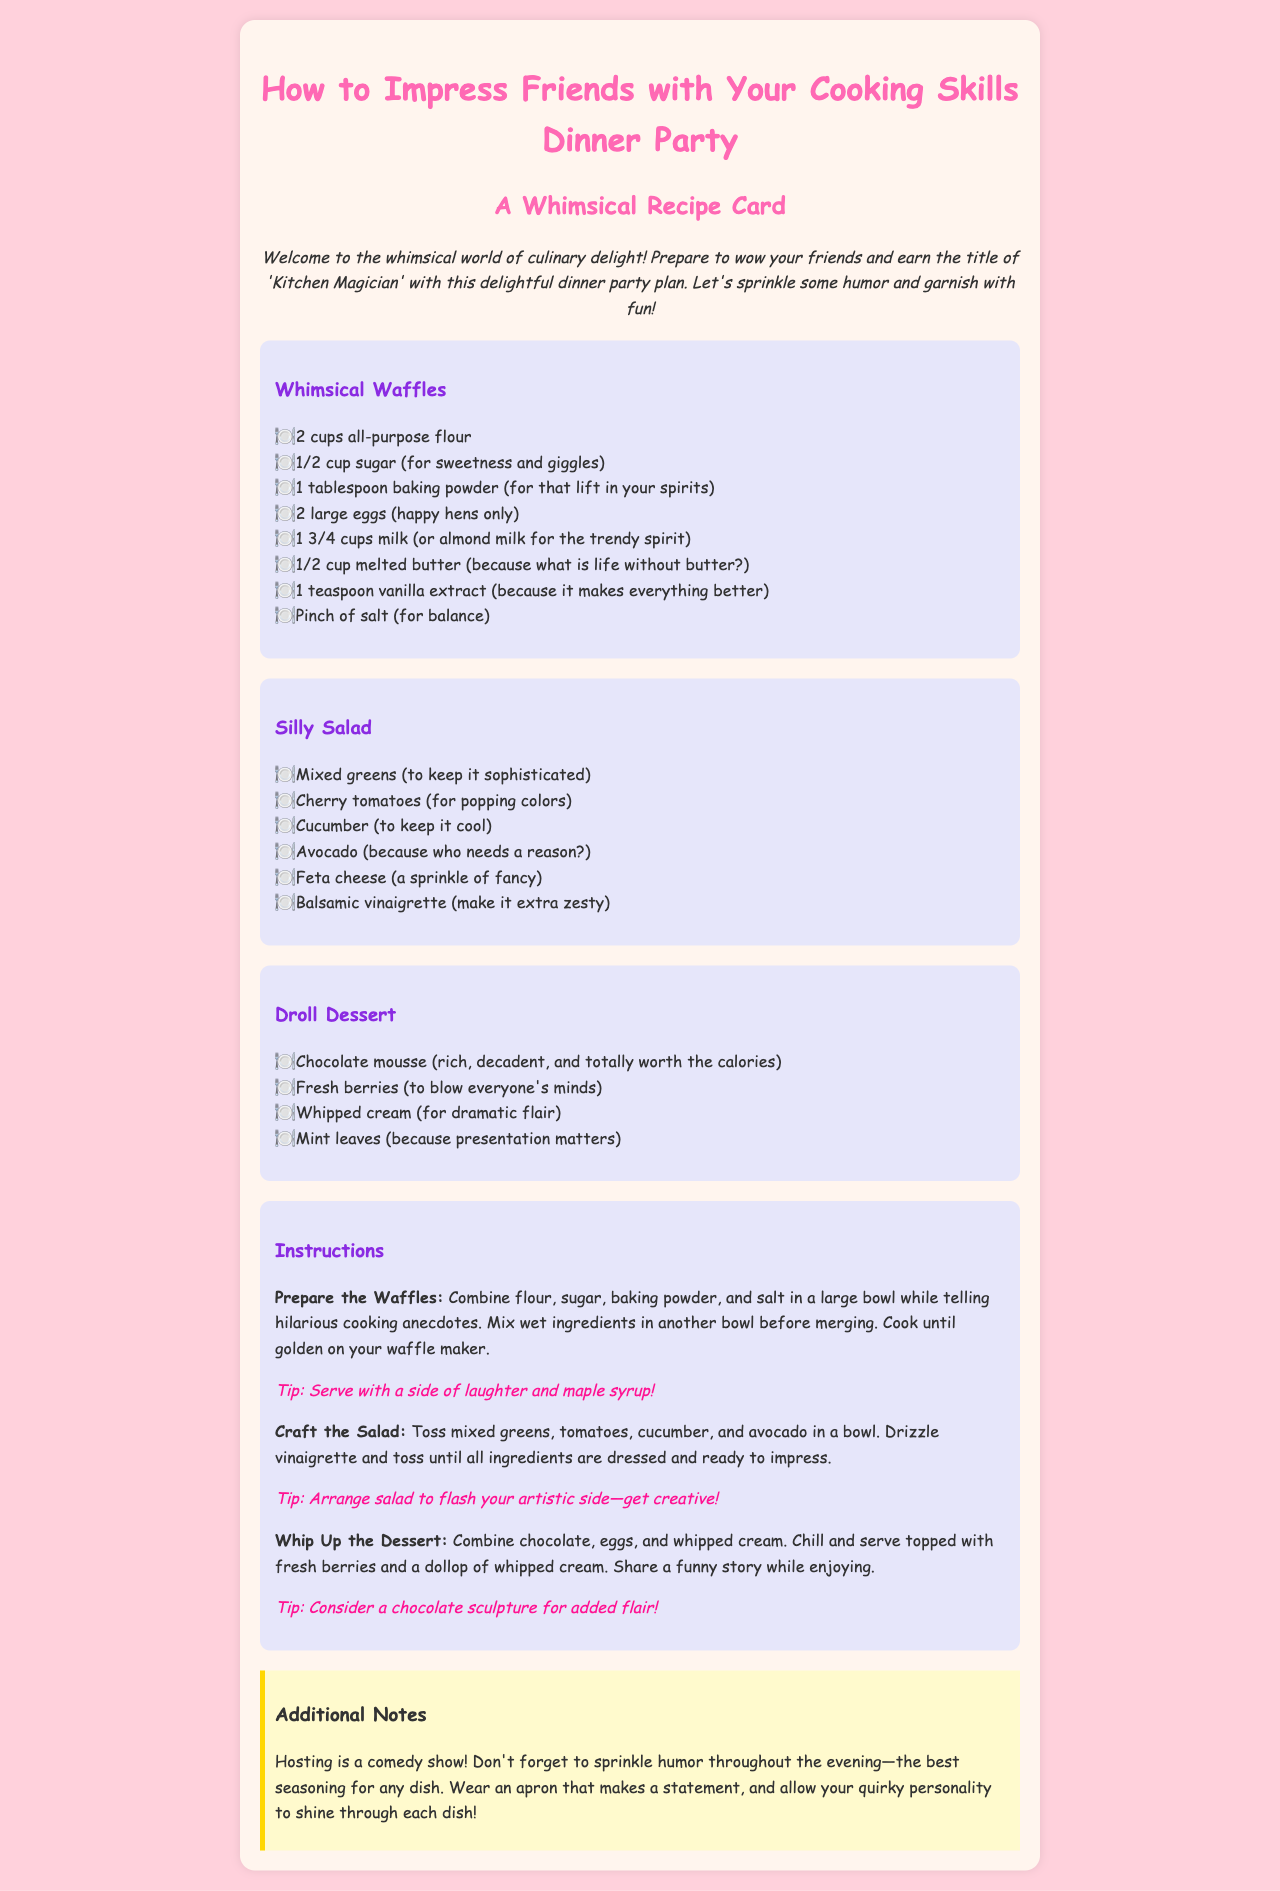What is the title of the document? The title of the document is found in the <title> tag of the HTML and is "Whimsical Recipe Card".
Answer: Whimsical Recipe Card How many cups of flour are needed for the waffles? The quantity of flour needed is specified in the ingredient list for Whimsical Waffles, which is 2 cups.
Answer: 2 cups What fancy cheese is listed in the Silly Salad ingredients? The cheese mentioned in the Silly Salad ingredient list is Feta cheese, providing a sprinkle of fancy.
Answer: Feta cheese What is a tip for serving the waffles? A tip for serving waffles is included in the instructions, stating to serve with a side of laughter and maple syrup.
Answer: Serve with a side of laughter and maple syrup Which ingredient adds richness to the Droll Dessert? The rich ingredient mentioned in the Droll Dessert is chocolate mousse, highlighted for its richness and decadence.
Answer: Chocolate mousse How many ingredients are listed for the Silly Salad? By counting the bullet points in the Silly Salad section, there are a total of 6 ingredients listed.
Answer: 6 What humorous advice is given for hosting? The humorous advice provided in the notes section suggests that hosting is a comedy show, emphasizing the importance of humor throughout the evening.
Answer: Hosting is a comedy show In which section are the cooking instructions found? The cooking instructions can be found in the section titled "Instructions" within the recipe card.
Answer: Instructions What color is used for the background of the document? The background color for the document is described in the style section and is #FFD1DC, a soft pink.
Answer: #FFD1DC 